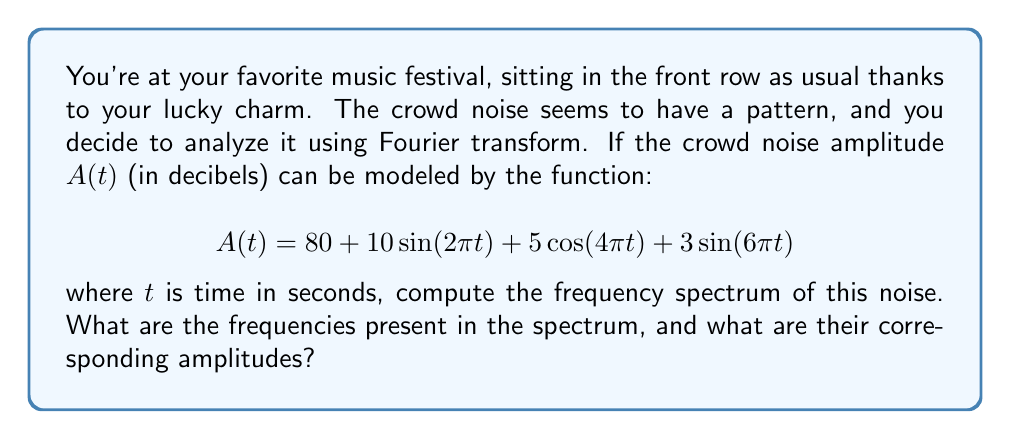What is the answer to this math problem? To find the frequency spectrum of the crowd noise, we need to identify the frequencies and amplitudes in the given function. The Fourier transform decomposes a signal into its constituent frequencies.

Let's analyze the function term by term:

1. Constant term: $80$
   This represents the DC component (0 Hz) with an amplitude of 80 dB.

2. $10\sin(2\pi t)$
   The frequency is $f_1 = \frac{\omega}{2\pi} = \frac{2\pi}{2\pi} = 1$ Hz
   The amplitude is 10 dB

3. $5\cos(4\pi t)$
   The frequency is $f_2 = \frac{\omega}{2\pi} = \frac{4\pi}{2\pi} = 2$ Hz
   The amplitude is 5 dB

4. $3\sin(6\pi t)$
   The frequency is $f_3 = \frac{\omega}{2\pi} = \frac{6\pi}{2\pi} = 3$ Hz
   The amplitude is 3 dB

The frequency spectrum consists of these four components: the DC component and three sinusoidal components at 1 Hz, 2 Hz, and 3 Hz.
Answer: The frequency spectrum of the crowd noise consists of:
- 0 Hz (DC component) with amplitude 80 dB
- 1 Hz with amplitude 10 dB
- 2 Hz with amplitude 5 dB
- 3 Hz with amplitude 3 dB 